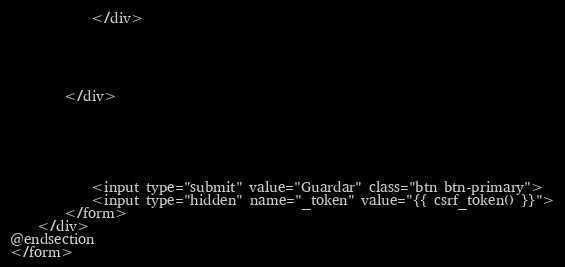<code> <loc_0><loc_0><loc_500><loc_500><_PHP_>			</div>





		</div>






			<input type="submit" value="Guardar" class="btn btn-primary">
			<input type="hidden" name="_token" value="{{ csrf_token() }}">
		</form>
	</div>
@endsection
</form>
</code> 